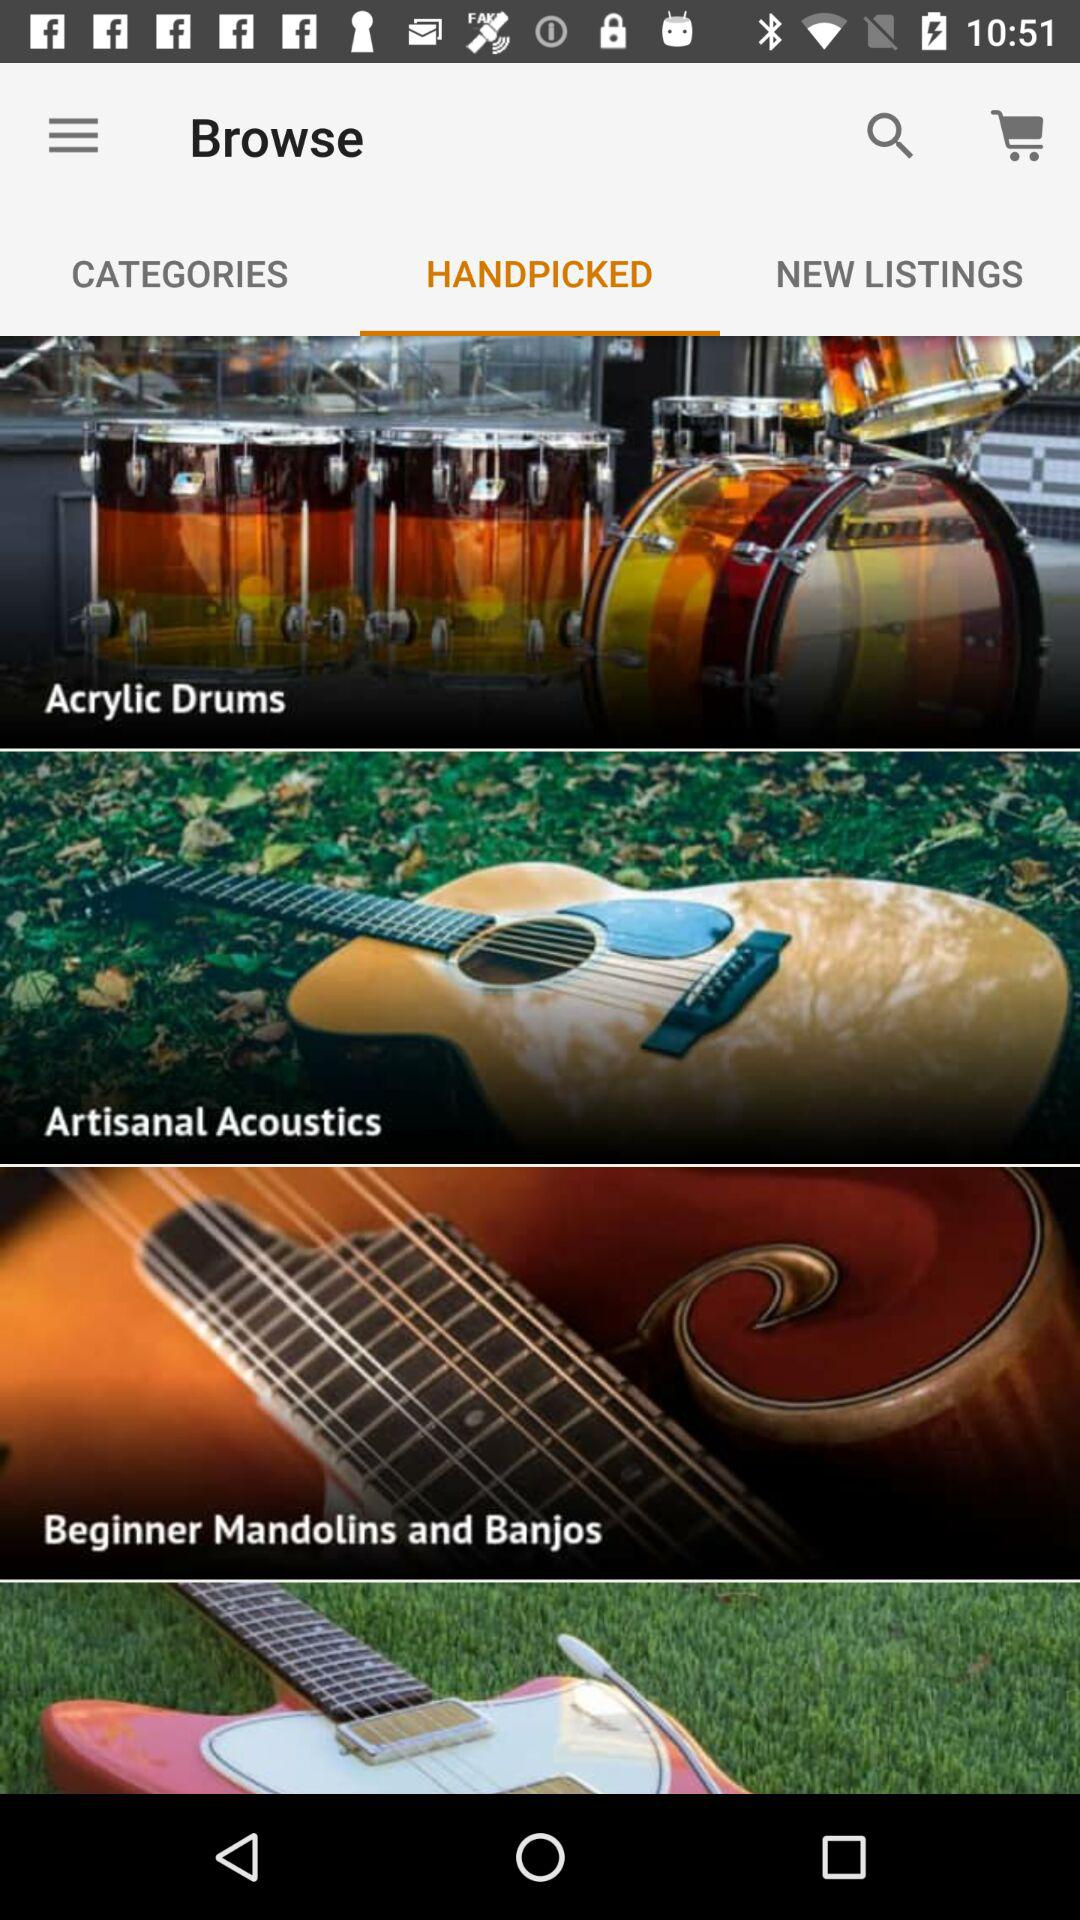Which tab has been selected? The selected tab is "HANDPICKED". 